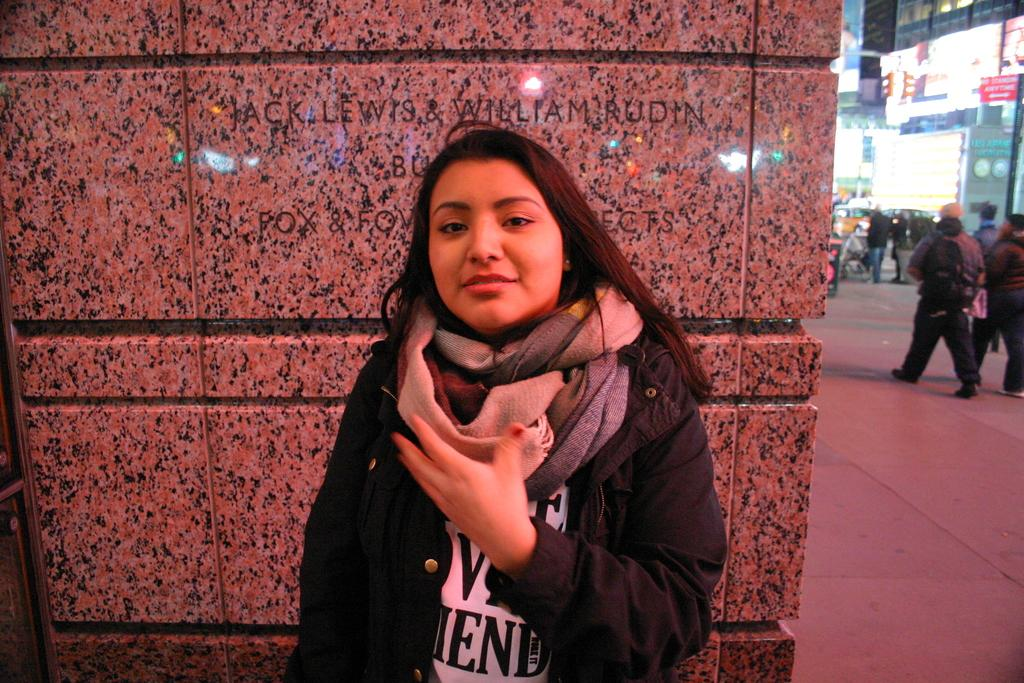Who is the main subject in the image? There is a woman in the image. What is the woman wearing? The woman is wearing a black jacket and scarf. Where is the woman standing? The woman is standing in front of a wall. What can be seen on the right side of the image? There are many people walking on the footpath on the right side of the image. What is visible in the background of the image? There are buildings visible in the background of the image. Where is the fire hydrant located in the image? There is no fire hydrant present in the image. How fast is the woman running in the image? The woman is not running in the image; she is standing still. 